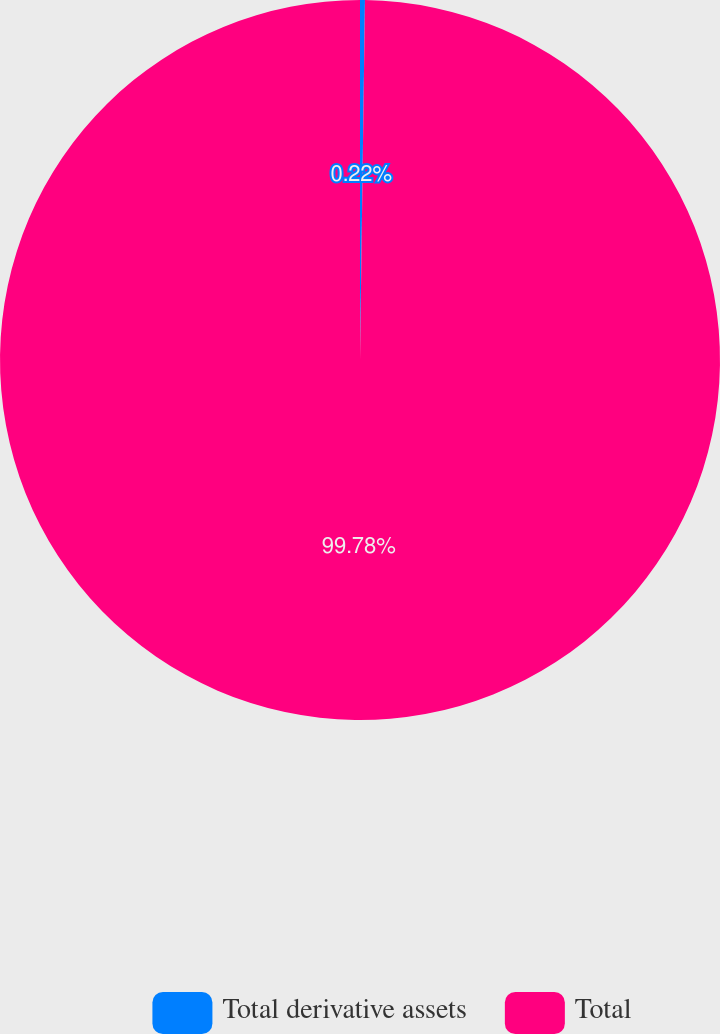Convert chart to OTSL. <chart><loc_0><loc_0><loc_500><loc_500><pie_chart><fcel>Total derivative assets<fcel>Total<nl><fcel>0.22%<fcel>99.78%<nl></chart> 